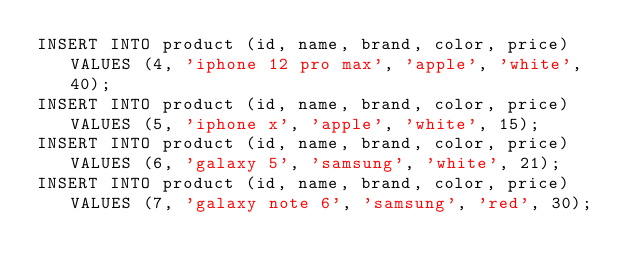Convert code to text. <code><loc_0><loc_0><loc_500><loc_500><_SQL_>INSERT INTO product (id, name, brand, color, price) VALUES (4, 'iphone 12 pro max', 'apple', 'white', 40);
INSERT INTO product (id, name, brand, color, price) VALUES (5, 'iphone x', 'apple', 'white', 15);
INSERT INTO product (id, name, brand, color, price) VALUES (6, 'galaxy 5', 'samsung', 'white', 21);
INSERT INTO product (id, name, brand, color, price) VALUES (7, 'galaxy note 6', 'samsung', 'red', 30);</code> 